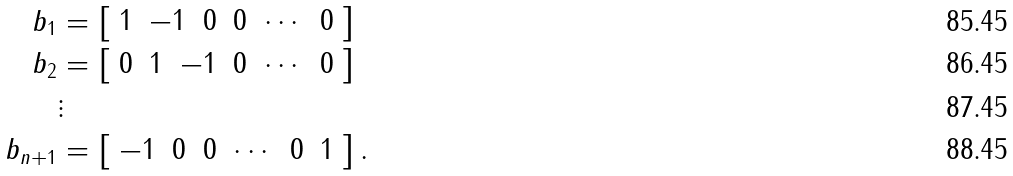<formula> <loc_0><loc_0><loc_500><loc_500>b _ { 1 } & = \left [ \begin{array} { r r r r r r r } 1 & - 1 & 0 & 0 & \cdots & 0 \end{array} \right ] \\ b _ { 2 } & = \left [ \begin{array} { r r r r r r r } 0 & 1 & - 1 & 0 & \cdots & 0 \end{array} \right ] \\ & \vdots \\ b _ { n + 1 } & = \left [ \begin{array} { r r r r r r r } - 1 & 0 & 0 & \cdots & 0 & 1 \end{array} \right ] .</formula> 